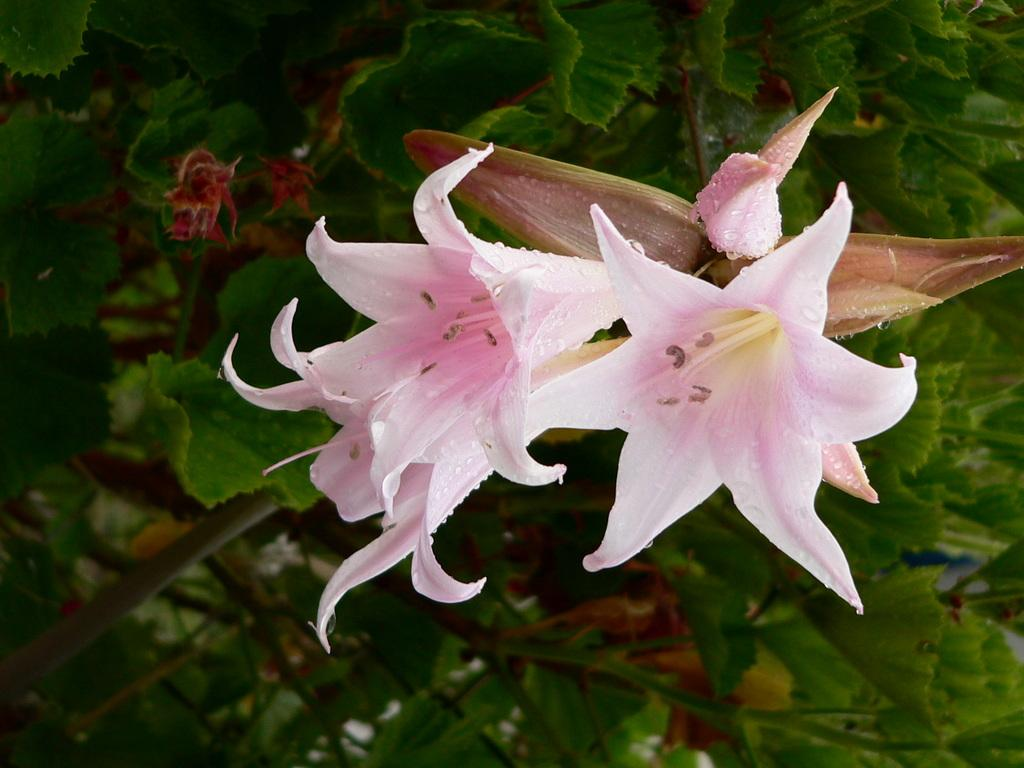What type of vegetation is in the foreground of the image? There are flowers in the foreground of the image. What type of vegetation is in the background of the image? There are plants in the background of the image. What is the condition of the elbow in the image? There is no elbow present in the image; it features flowers and plants. What is the chance of winning a prize in the image? There is no reference to a prize or winning in the image, as it features flowers and plants. 